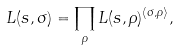Convert formula to latex. <formula><loc_0><loc_0><loc_500><loc_500>L ( s , \sigma ) = \prod _ { \rho } L ( s , \rho ) ^ { \langle \sigma , \rho \rangle } ,</formula> 